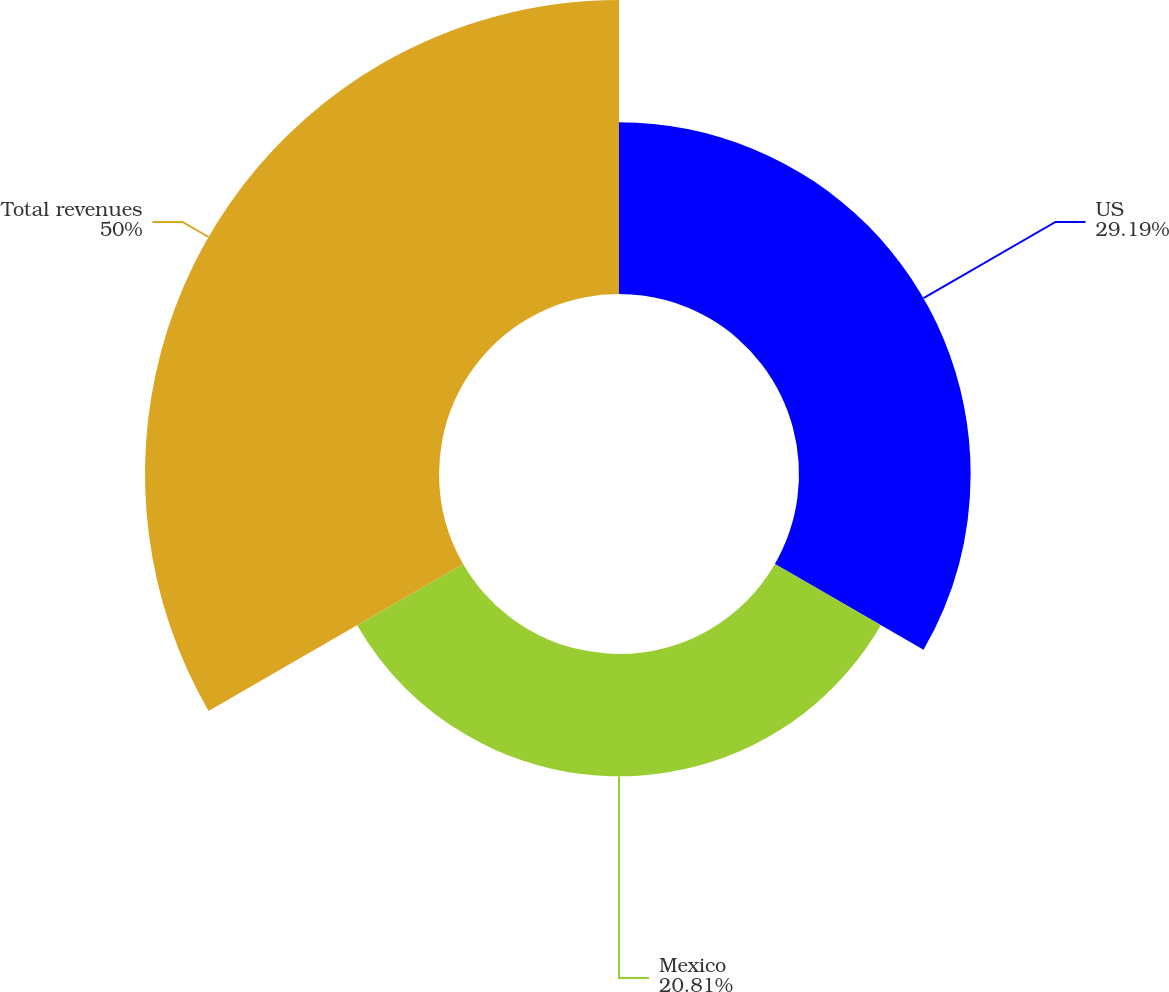Convert chart. <chart><loc_0><loc_0><loc_500><loc_500><pie_chart><fcel>US<fcel>Mexico<fcel>Total revenues<nl><fcel>29.19%<fcel>20.81%<fcel>50.0%<nl></chart> 